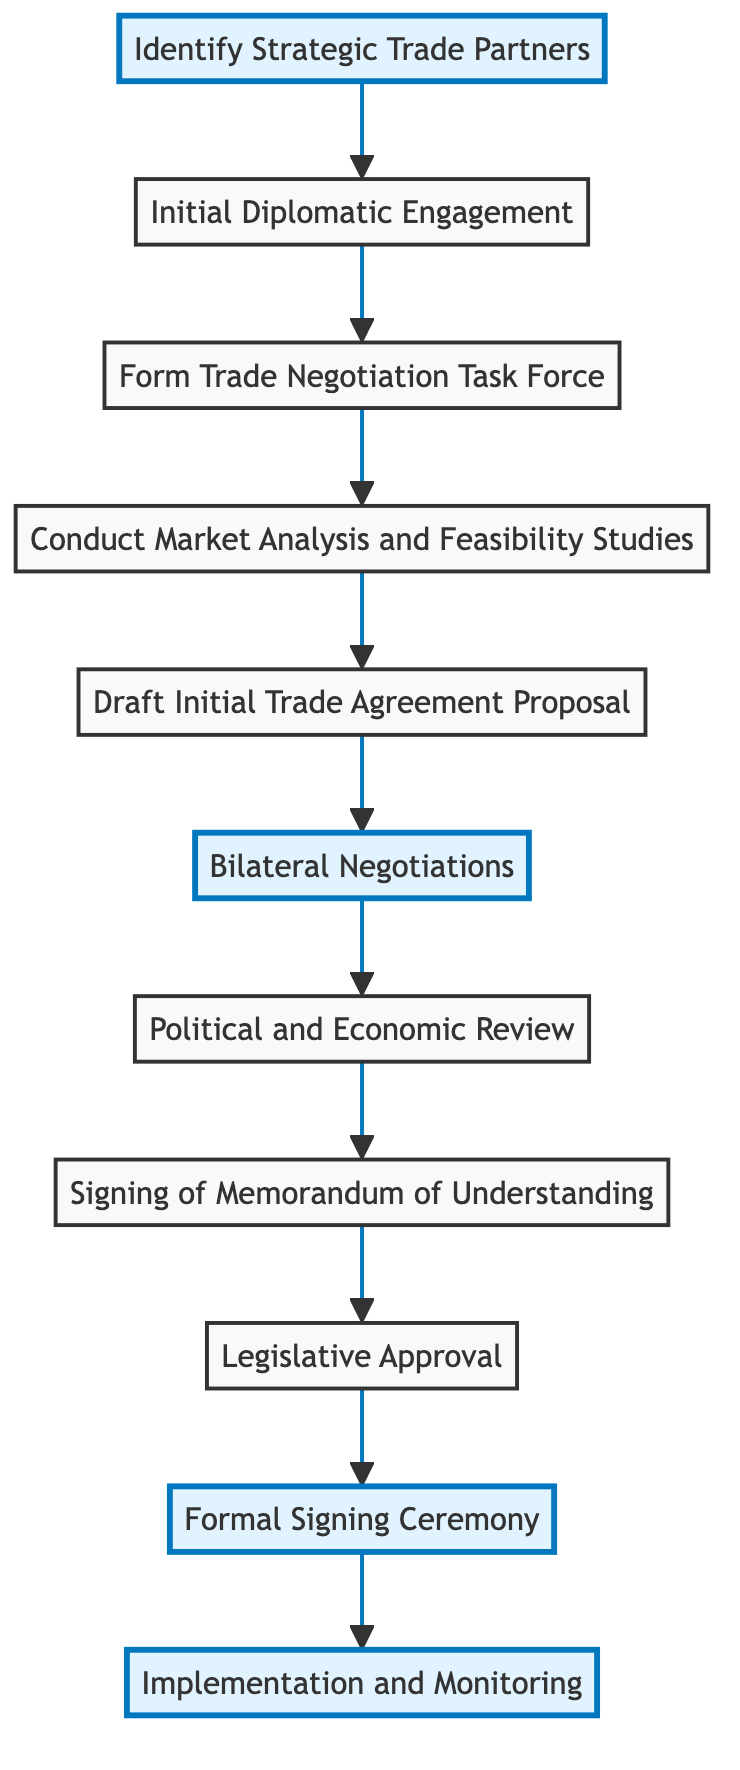What is the first step in establishing bilateral trade partnerships? The first step is "Identify Strategic Trade Partners," which is indicated as the very first node in the flowchart.
Answer: Identify Strategic Trade Partners How many total steps are there in the flowchart? By counting all the nodes in the flowchart, there are a total of 11 steps listed.
Answer: 11 What comes after the "Draft Initial Trade Agreement Proposal"? Following the "Draft Initial Trade Agreement Proposal," the next step is "Bilateral Negotiations," as demonstrated by the connecting arrow leading to that node.
Answer: Bilateral Negotiations What does the "Political and Economic Review" step entail? The "Political and Economic Review" step involves both governments conducting reviews and assessments of the proposed trade agreement, based on the description provided in the flowchart.
Answer: Conduct reviews and assessments Which step in the flowchart features a formal signing ceremony? The step that features a formal signing ceremony is "Formal Signing Ceremony," as explicitly indicated in that node.
Answer: Formal Signing Ceremony What is the final step in the flowchart process? The final step in the flowchart is "Implementation and Monitoring," which is also the last node that ends the flow.
Answer: Implementation and Monitoring In which step is a non-binding MOU signed? A non-binding Memorandum of Understanding (MOU) is signed in the step called "Signing of Memorandum of Understanding," as shown in the corresponding node.
Answer: Signing of Memorandum of Understanding Which two highlighted steps indicate critical milestones? The two highlighted steps indicating critical milestones are "Identify Strategic Trade Partners" and "Formal Signing Ceremony," as they are emphasized differently within the diagram.
Answer: Identify Strategic Trade Partners and Formal Signing Ceremony What is the immediate step after signing the MOU? The immediate step after signing the MOU is "Legislative Approval," which follows in the flowchart after the MOU step.
Answer: Legislative Approval 